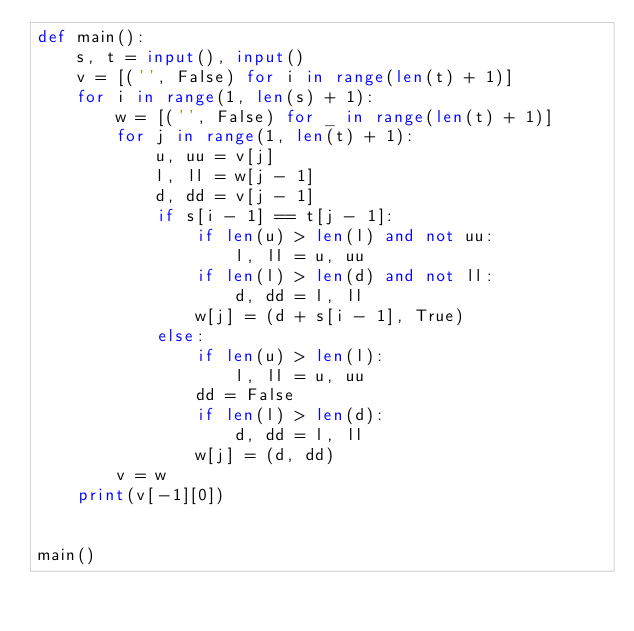<code> <loc_0><loc_0><loc_500><loc_500><_Python_>def main():
    s, t = input(), input()
    v = [('', False) for i in range(len(t) + 1)]
    for i in range(1, len(s) + 1):
        w = [('', False) for _ in range(len(t) + 1)]
        for j in range(1, len(t) + 1):
            u, uu = v[j]
            l, ll = w[j - 1]
            d, dd = v[j - 1]
            if s[i - 1] == t[j - 1]:
                if len(u) > len(l) and not uu:
                    l, ll = u, uu 
                if len(l) > len(d) and not ll:
                    d, dd = l, ll
                w[j] = (d + s[i - 1], True)
            else:
                if len(u) > len(l):
                    l, ll = u, uu
                dd = False
                if len(l) > len(d):
                    d, dd = l, ll
                w[j] = (d, dd)
        v = w
    print(v[-1][0])


main()
</code> 